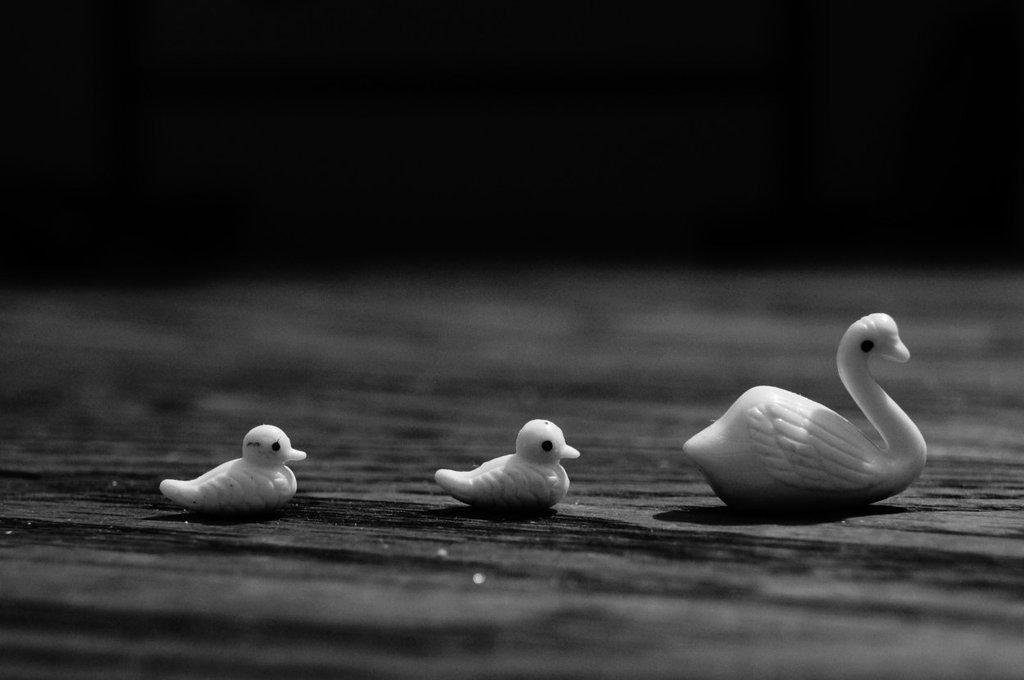How many toys can be seen in the image? There are three toys in the image. Where are the toys located? The toys are on a surface in the image. What can be observed about the background of the image? The background of the image is dark. What type of ocean can be seen in the background of the image? There is no ocean present in the image; the background is dark. What selection of countries is depicted in the image? There is no depiction of countries in the image; it features three toys on a surface. 